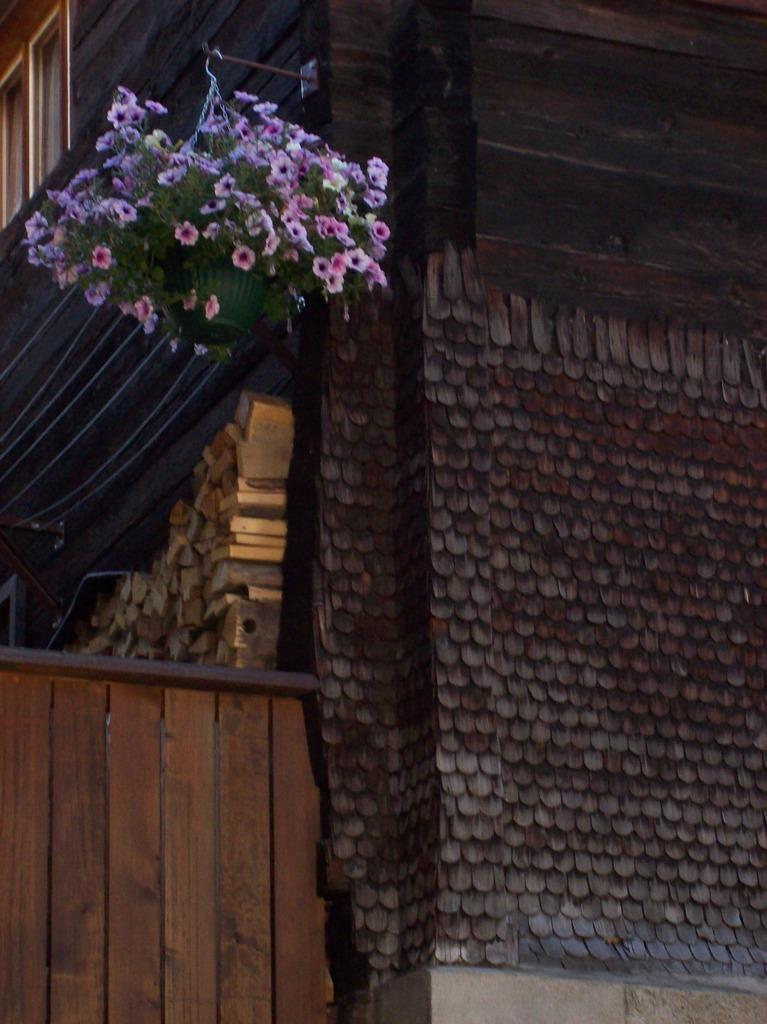What type of plant can be seen in the image? There is a flower plant in the image. What architectural feature is present in the image? There is a window in the image. What type of structures can be seen in the distance? There are buildings visible in the image. What type of barrier is present in the image? There is a wooden fence in the image. What type of material is used for the logs in the image? There are wooden logs in the image. What type of fastening device is present in the image? There are chains in the image. What type of discovery was made by the plants in the image? There is no discovery mentioned in the image, as it is a static image of a flower plant, window, buildings, wooden fence, wooden logs, and chains. What color is the scarf worn by the plants in the image? There are no plants wearing scarves in the image, as plants do not wear clothing. 